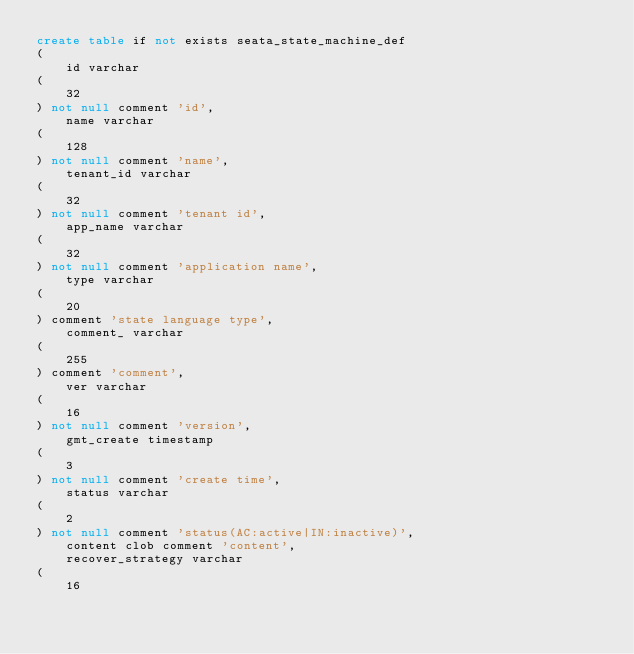Convert code to text. <code><loc_0><loc_0><loc_500><loc_500><_SQL_>create table if not exists seata_state_machine_def
(
    id varchar
(
    32
) not null comment 'id',
    name varchar
(
    128
) not null comment 'name',
    tenant_id varchar
(
    32
) not null comment 'tenant id',
    app_name varchar
(
    32
) not null comment 'application name',
    type varchar
(
    20
) comment 'state language type',
    comment_ varchar
(
    255
) comment 'comment',
    ver varchar
(
    16
) not null comment 'version',
    gmt_create timestamp
(
    3
) not null comment 'create time',
    status varchar
(
    2
) not null comment 'status(AC:active|IN:inactive)',
    content clob comment 'content',
    recover_strategy varchar
(
    16</code> 